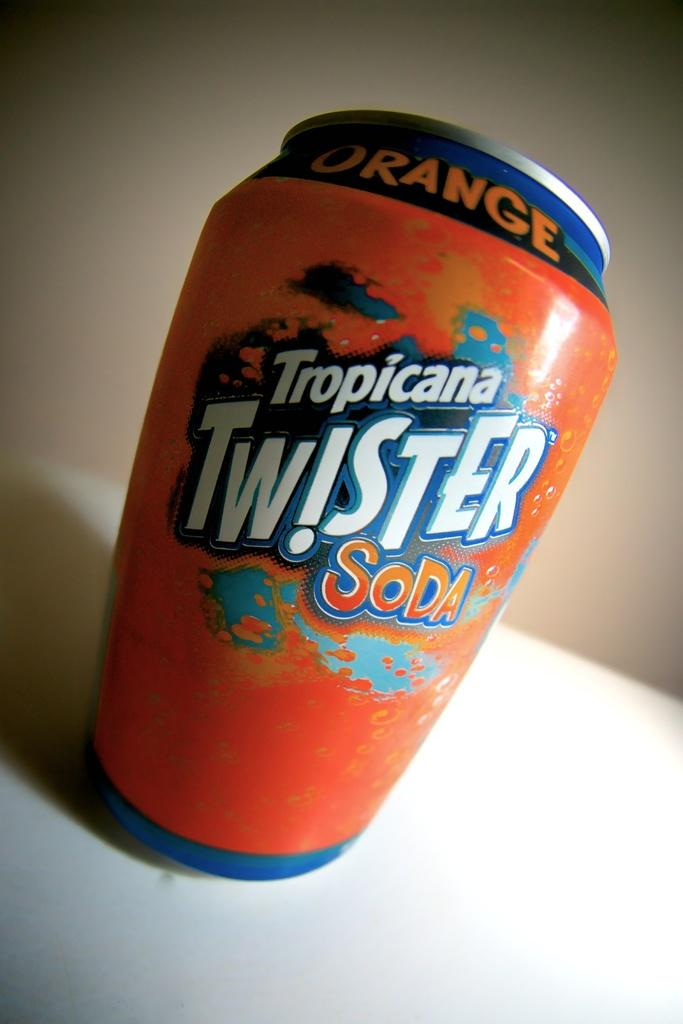<image>
Give a short and clear explanation of the subsequent image. A can of orange Tropicana Twister Soda on a table. 